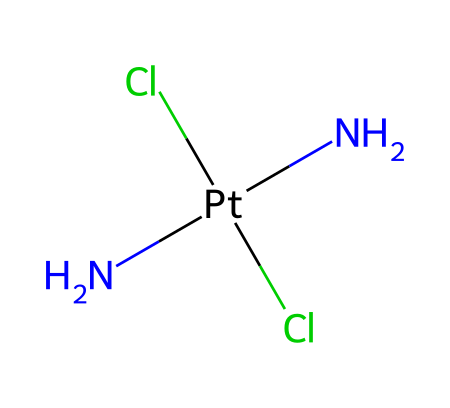What is the central metal atom in this compound? The central metal atom in the structure is indicated by "Pt" in the SMILES notation, which stands for platinum.
Answer: platinum How many chlorine atoms are present in the structure? The SMILES notation shows "Cl" occurring twice, indicating there are two chlorine atoms in the compound.
Answer: two What is the total number of nitrogen atoms in this chemical? The notation "N" appears twice, indicating that there are two nitrogen atoms in the chemical structure.
Answer: two Is this compound a cation or an anion? The presence of positive coordination around the metal (e.g., N[Pt] which indicates the metal has a positive charge due to coordination by the nitrogen) indicates that this compound is a cation.
Answer: cation What type of chemical bond primarily connects the nitrogen atoms to the platinum? The bonds formed between nitrogen and platinum are coordinate covalent bonds, as nitrogen donates a lone pair to form these bonds with the metal.
Answer: coordinate covalent What functional groups are present in this organometallic compound? The presence of the nitrogen (N) and chlorine (Cl) atoms suggests that the functional groups include amine (from nitrogen) and halide (from chlorine).
Answer: amine and halide What is the overall coordination number of the platinum in this compound? The coordination number pertains to the number of ligand bonds around the central metal atom. In this case, platinum is surrounded by four groups (two nitrogen and two chlorine), resulting in a coordination number of four.
Answer: four 